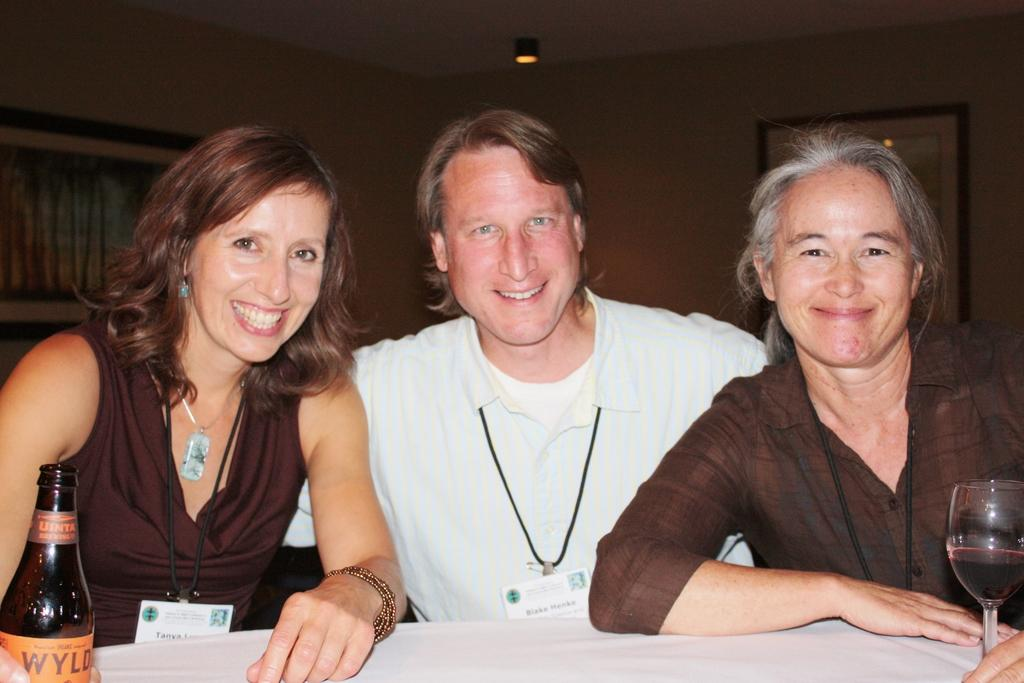What is the person in the image doing? The person is sitting at a table. What is on the table with the person? There is a glass and beer on the table. What can be seen in the background of the image? There is a wall and photo frames in the background. How many cows are visible in the photo frames in the background? There are no cows visible in the photo frames in the background; they contain images or decorations. 